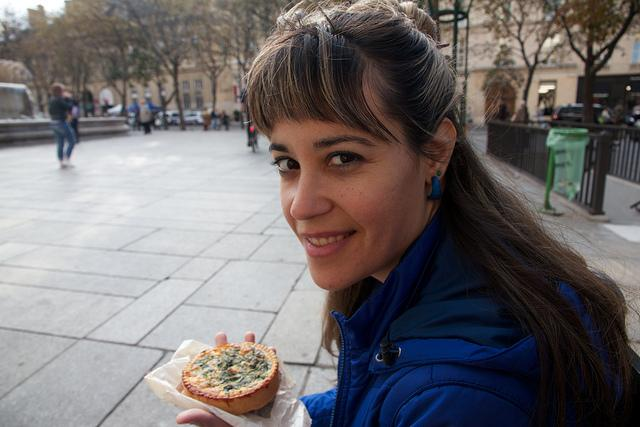What material are the earrings made of? Please explain your reasoning. metal. The studs need to be hard enough to pass through the hole in the ear. 